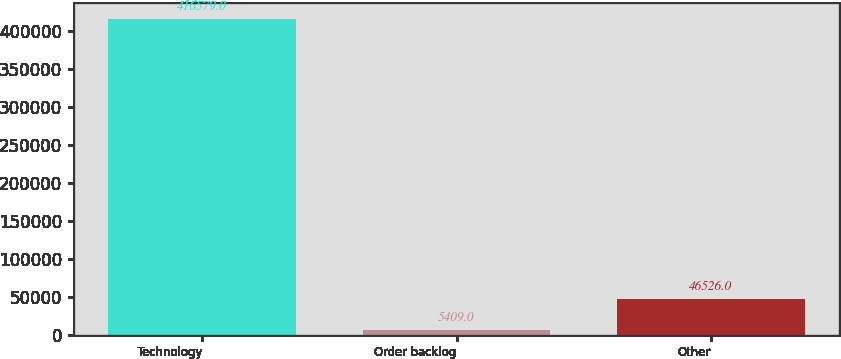<chart> <loc_0><loc_0><loc_500><loc_500><bar_chart><fcel>Technology<fcel>Order backlog<fcel>Other<nl><fcel>416579<fcel>5409<fcel>46526<nl></chart> 